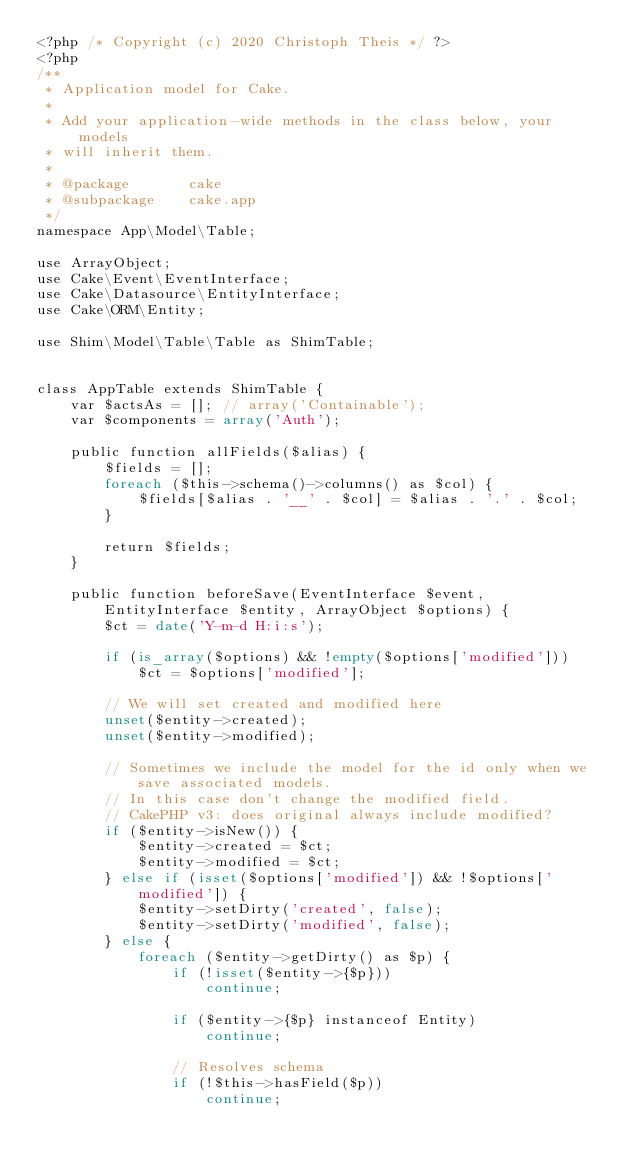<code> <loc_0><loc_0><loc_500><loc_500><_PHP_><?php /* Copyright (c) 2020 Christoph Theis */ ?>
<?php
/**
 * Application model for Cake.
 *
 * Add your application-wide methods in the class below, your models
 * will inherit them.
 *
 * @package       cake
 * @subpackage    cake.app
 */
namespace App\Model\Table;

use ArrayObject;
use Cake\Event\EventInterface;
use Cake\Datasource\EntityInterface;
use Cake\ORM\Entity;

use Shim\Model\Table\Table as ShimTable;


class AppTable extends ShimTable {
	var $actsAs = []; // array('Containable');
	var $components = array('Auth');
	
	public function allFields($alias) {
		$fields = [];
		foreach ($this->schema()->columns() as $col) {
			$fields[$alias . '__' . $col] = $alias . '.' . $col;
		}
		
		return $fields;
	}

	public function beforeSave(EventInterface $event, EntityInterface $entity, ArrayObject $options) {
		$ct = date('Y-m-d H:i:s');
		
		if (is_array($options) && !empty($options['modified'])) 
			$ct = $options['modified'];
		
		// We will set created and modified here
		unset($entity->created);
		unset($entity->modified);

		// Sometimes we include the model for the id only when we save associated models.
		// In this case don't change the modified field.
		// CakePHP v3: does original always include modified?
		if ($entity->isNew()) {
			$entity->created = $ct;
			$entity->modified = $ct;
		} else if (isset($options['modified']) && !$options['modified']) {
			$entity->setDirty('created', false);
			$entity->setDirty('modified', false);
		} else {
			foreach ($entity->getDirty() as $p) {
				if (!isset($entity->{$p}))
					continue;
				
				if ($entity->{$p} instanceof Entity)
					continue;

				// Resolves schema
				if (!$this->hasField($p))
					continue;
				</code> 